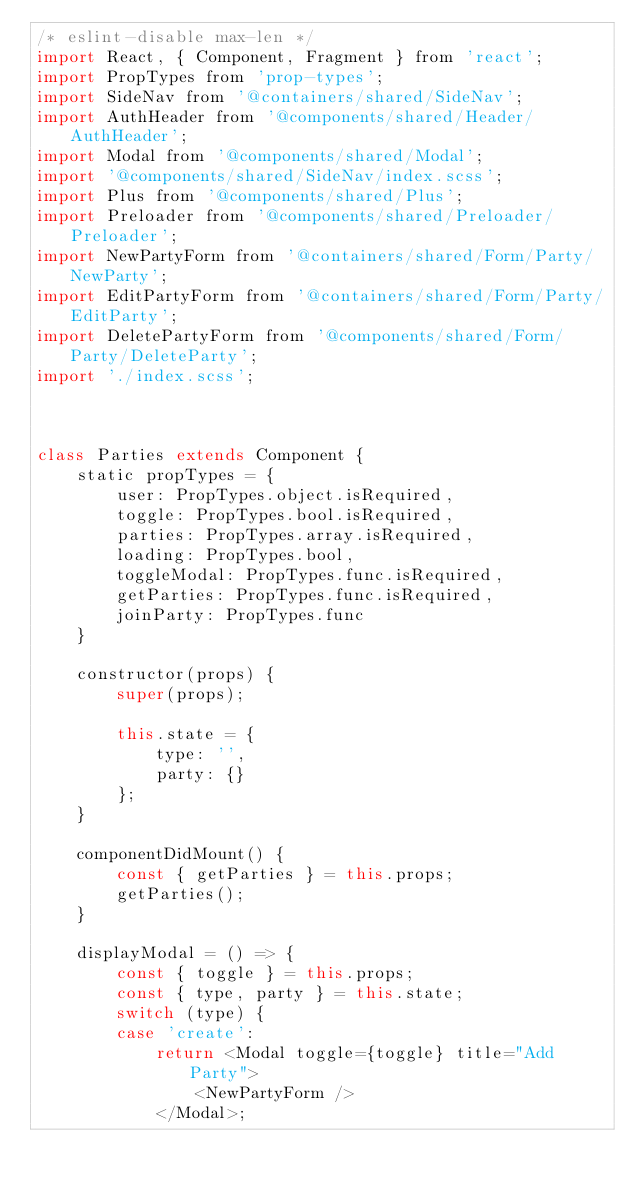Convert code to text. <code><loc_0><loc_0><loc_500><loc_500><_JavaScript_>/* eslint-disable max-len */
import React, { Component, Fragment } from 'react';
import PropTypes from 'prop-types';
import SideNav from '@containers/shared/SideNav';
import AuthHeader from '@components/shared/Header/AuthHeader';
import Modal from '@components/shared/Modal';
import '@components/shared/SideNav/index.scss';
import Plus from '@components/shared/Plus';
import Preloader from '@components/shared/Preloader/Preloader';
import NewPartyForm from '@containers/shared/Form/Party/NewParty';
import EditPartyForm from '@containers/shared/Form/Party/EditParty';
import DeletePartyForm from '@components/shared/Form/Party/DeleteParty';
import './index.scss';



class Parties extends Component {
    static propTypes = {
        user: PropTypes.object.isRequired,
        toggle: PropTypes.bool.isRequired,
        parties: PropTypes.array.isRequired,
        loading: PropTypes.bool,
        toggleModal: PropTypes.func.isRequired,
        getParties: PropTypes.func.isRequired,
        joinParty: PropTypes.func
    }

    constructor(props) {
        super(props);

        this.state = {
            type: '',
            party: {}
        };
    }

    componentDidMount() {
        const { getParties } = this.props;
        getParties();
    }

    displayModal = () => {
        const { toggle } = this.props;
        const { type, party } = this.state;
        switch (type) {
        case 'create':
            return <Modal toggle={toggle} title="Add Party">
                <NewPartyForm />
            </Modal>;</code> 